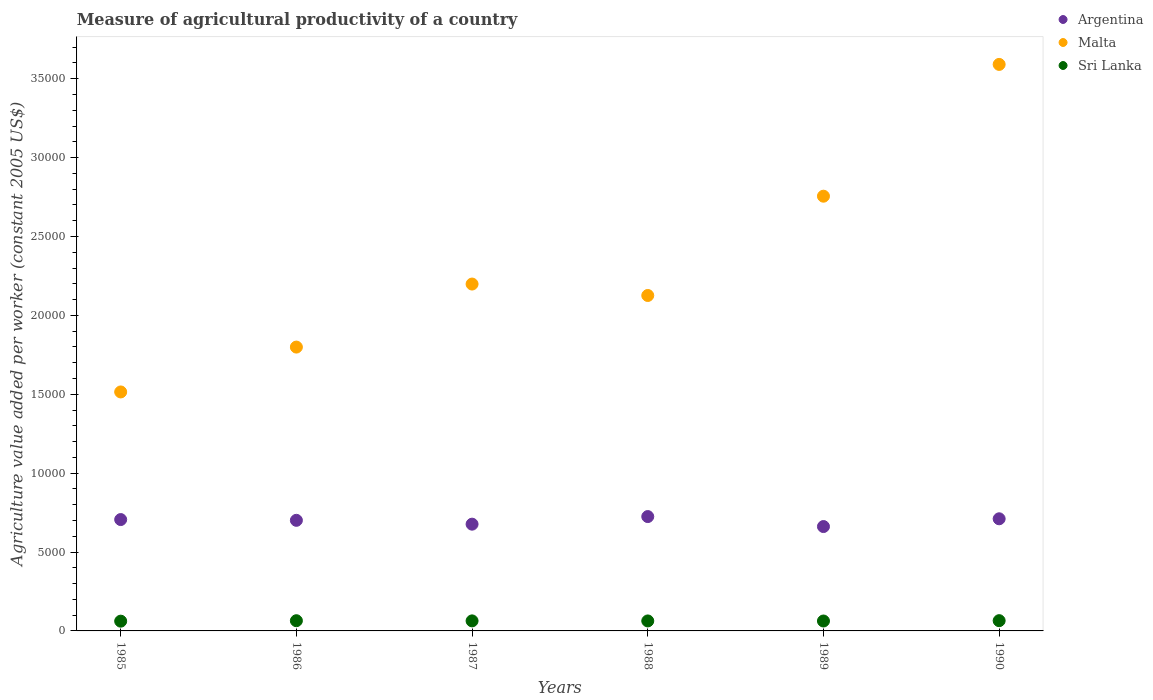What is the measure of agricultural productivity in Sri Lanka in 1986?
Offer a terse response. 646.87. Across all years, what is the maximum measure of agricultural productivity in Malta?
Your answer should be compact. 3.59e+04. Across all years, what is the minimum measure of agricultural productivity in Sri Lanka?
Your answer should be very brief. 618.17. In which year was the measure of agricultural productivity in Malta maximum?
Give a very brief answer. 1990. What is the total measure of agricultural productivity in Sri Lanka in the graph?
Give a very brief answer. 3811.92. What is the difference between the measure of agricultural productivity in Sri Lanka in 1987 and that in 1990?
Give a very brief answer. -14.21. What is the difference between the measure of agricultural productivity in Sri Lanka in 1985 and the measure of agricultural productivity in Malta in 1987?
Your answer should be very brief. -2.14e+04. What is the average measure of agricultural productivity in Argentina per year?
Offer a terse response. 6967.93. In the year 1985, what is the difference between the measure of agricultural productivity in Malta and measure of agricultural productivity in Argentina?
Give a very brief answer. 8089.08. In how many years, is the measure of agricultural productivity in Sri Lanka greater than 25000 US$?
Provide a succinct answer. 0. What is the ratio of the measure of agricultural productivity in Malta in 1987 to that in 1989?
Offer a very short reply. 0.8. Is the measure of agricultural productivity in Sri Lanka in 1986 less than that in 1988?
Make the answer very short. No. Is the difference between the measure of agricultural productivity in Malta in 1986 and 1988 greater than the difference between the measure of agricultural productivity in Argentina in 1986 and 1988?
Make the answer very short. No. What is the difference between the highest and the second highest measure of agricultural productivity in Sri Lanka?
Your answer should be very brief. 3.16. What is the difference between the highest and the lowest measure of agricultural productivity in Sri Lanka?
Provide a short and direct response. 31.86. In how many years, is the measure of agricultural productivity in Argentina greater than the average measure of agricultural productivity in Argentina taken over all years?
Keep it short and to the point. 4. Is it the case that in every year, the sum of the measure of agricultural productivity in Sri Lanka and measure of agricultural productivity in Malta  is greater than the measure of agricultural productivity in Argentina?
Keep it short and to the point. Yes. Is the measure of agricultural productivity in Malta strictly greater than the measure of agricultural productivity in Sri Lanka over the years?
Your answer should be compact. Yes. How many years are there in the graph?
Keep it short and to the point. 6. What is the difference between two consecutive major ticks on the Y-axis?
Offer a very short reply. 5000. Does the graph contain any zero values?
Offer a terse response. No. How many legend labels are there?
Offer a terse response. 3. What is the title of the graph?
Offer a very short reply. Measure of agricultural productivity of a country. What is the label or title of the X-axis?
Offer a terse response. Years. What is the label or title of the Y-axis?
Keep it short and to the point. Agriculture value added per worker (constant 2005 US$). What is the Agriculture value added per worker (constant 2005 US$) of Argentina in 1985?
Keep it short and to the point. 7058.64. What is the Agriculture value added per worker (constant 2005 US$) in Malta in 1985?
Provide a short and direct response. 1.51e+04. What is the Agriculture value added per worker (constant 2005 US$) in Sri Lanka in 1985?
Offer a very short reply. 618.17. What is the Agriculture value added per worker (constant 2005 US$) in Argentina in 1986?
Make the answer very short. 7010.49. What is the Agriculture value added per worker (constant 2005 US$) in Malta in 1986?
Your answer should be very brief. 1.80e+04. What is the Agriculture value added per worker (constant 2005 US$) in Sri Lanka in 1986?
Your response must be concise. 646.87. What is the Agriculture value added per worker (constant 2005 US$) in Argentina in 1987?
Make the answer very short. 6766.74. What is the Agriculture value added per worker (constant 2005 US$) in Malta in 1987?
Keep it short and to the point. 2.20e+04. What is the Agriculture value added per worker (constant 2005 US$) in Sri Lanka in 1987?
Keep it short and to the point. 635.83. What is the Agriculture value added per worker (constant 2005 US$) in Argentina in 1988?
Your answer should be compact. 7248.35. What is the Agriculture value added per worker (constant 2005 US$) of Malta in 1988?
Make the answer very short. 2.13e+04. What is the Agriculture value added per worker (constant 2005 US$) in Sri Lanka in 1988?
Offer a terse response. 632.87. What is the Agriculture value added per worker (constant 2005 US$) of Argentina in 1989?
Give a very brief answer. 6615.78. What is the Agriculture value added per worker (constant 2005 US$) of Malta in 1989?
Make the answer very short. 2.76e+04. What is the Agriculture value added per worker (constant 2005 US$) of Sri Lanka in 1989?
Provide a succinct answer. 628.14. What is the Agriculture value added per worker (constant 2005 US$) of Argentina in 1990?
Keep it short and to the point. 7107.59. What is the Agriculture value added per worker (constant 2005 US$) in Malta in 1990?
Your answer should be compact. 3.59e+04. What is the Agriculture value added per worker (constant 2005 US$) of Sri Lanka in 1990?
Provide a short and direct response. 650.03. Across all years, what is the maximum Agriculture value added per worker (constant 2005 US$) in Argentina?
Offer a very short reply. 7248.35. Across all years, what is the maximum Agriculture value added per worker (constant 2005 US$) of Malta?
Your response must be concise. 3.59e+04. Across all years, what is the maximum Agriculture value added per worker (constant 2005 US$) of Sri Lanka?
Provide a succinct answer. 650.03. Across all years, what is the minimum Agriculture value added per worker (constant 2005 US$) of Argentina?
Offer a very short reply. 6615.78. Across all years, what is the minimum Agriculture value added per worker (constant 2005 US$) in Malta?
Your response must be concise. 1.51e+04. Across all years, what is the minimum Agriculture value added per worker (constant 2005 US$) in Sri Lanka?
Provide a succinct answer. 618.17. What is the total Agriculture value added per worker (constant 2005 US$) of Argentina in the graph?
Make the answer very short. 4.18e+04. What is the total Agriculture value added per worker (constant 2005 US$) of Malta in the graph?
Provide a short and direct response. 1.40e+05. What is the total Agriculture value added per worker (constant 2005 US$) of Sri Lanka in the graph?
Give a very brief answer. 3811.92. What is the difference between the Agriculture value added per worker (constant 2005 US$) in Argentina in 1985 and that in 1986?
Make the answer very short. 48.16. What is the difference between the Agriculture value added per worker (constant 2005 US$) in Malta in 1985 and that in 1986?
Ensure brevity in your answer.  -2843.98. What is the difference between the Agriculture value added per worker (constant 2005 US$) of Sri Lanka in 1985 and that in 1986?
Your answer should be very brief. -28.7. What is the difference between the Agriculture value added per worker (constant 2005 US$) of Argentina in 1985 and that in 1987?
Provide a succinct answer. 291.9. What is the difference between the Agriculture value added per worker (constant 2005 US$) in Malta in 1985 and that in 1987?
Give a very brief answer. -6839.31. What is the difference between the Agriculture value added per worker (constant 2005 US$) in Sri Lanka in 1985 and that in 1987?
Your answer should be very brief. -17.65. What is the difference between the Agriculture value added per worker (constant 2005 US$) in Argentina in 1985 and that in 1988?
Make the answer very short. -189.71. What is the difference between the Agriculture value added per worker (constant 2005 US$) in Malta in 1985 and that in 1988?
Provide a succinct answer. -6114.57. What is the difference between the Agriculture value added per worker (constant 2005 US$) of Sri Lanka in 1985 and that in 1988?
Provide a short and direct response. -14.7. What is the difference between the Agriculture value added per worker (constant 2005 US$) of Argentina in 1985 and that in 1989?
Provide a succinct answer. 442.86. What is the difference between the Agriculture value added per worker (constant 2005 US$) of Malta in 1985 and that in 1989?
Your answer should be compact. -1.24e+04. What is the difference between the Agriculture value added per worker (constant 2005 US$) in Sri Lanka in 1985 and that in 1989?
Provide a succinct answer. -9.97. What is the difference between the Agriculture value added per worker (constant 2005 US$) of Argentina in 1985 and that in 1990?
Offer a very short reply. -48.95. What is the difference between the Agriculture value added per worker (constant 2005 US$) in Malta in 1985 and that in 1990?
Make the answer very short. -2.08e+04. What is the difference between the Agriculture value added per worker (constant 2005 US$) of Sri Lanka in 1985 and that in 1990?
Your answer should be compact. -31.86. What is the difference between the Agriculture value added per worker (constant 2005 US$) in Argentina in 1986 and that in 1987?
Offer a very short reply. 243.75. What is the difference between the Agriculture value added per worker (constant 2005 US$) in Malta in 1986 and that in 1987?
Your answer should be very brief. -3995.34. What is the difference between the Agriculture value added per worker (constant 2005 US$) of Sri Lanka in 1986 and that in 1987?
Your response must be concise. 11.05. What is the difference between the Agriculture value added per worker (constant 2005 US$) in Argentina in 1986 and that in 1988?
Offer a terse response. -237.87. What is the difference between the Agriculture value added per worker (constant 2005 US$) of Malta in 1986 and that in 1988?
Your answer should be compact. -3270.59. What is the difference between the Agriculture value added per worker (constant 2005 US$) of Sri Lanka in 1986 and that in 1988?
Offer a very short reply. 14. What is the difference between the Agriculture value added per worker (constant 2005 US$) in Argentina in 1986 and that in 1989?
Your answer should be compact. 394.7. What is the difference between the Agriculture value added per worker (constant 2005 US$) of Malta in 1986 and that in 1989?
Offer a very short reply. -9564.66. What is the difference between the Agriculture value added per worker (constant 2005 US$) of Sri Lanka in 1986 and that in 1989?
Make the answer very short. 18.73. What is the difference between the Agriculture value added per worker (constant 2005 US$) in Argentina in 1986 and that in 1990?
Offer a very short reply. -97.11. What is the difference between the Agriculture value added per worker (constant 2005 US$) of Malta in 1986 and that in 1990?
Ensure brevity in your answer.  -1.79e+04. What is the difference between the Agriculture value added per worker (constant 2005 US$) in Sri Lanka in 1986 and that in 1990?
Offer a very short reply. -3.16. What is the difference between the Agriculture value added per worker (constant 2005 US$) of Argentina in 1987 and that in 1988?
Offer a terse response. -481.61. What is the difference between the Agriculture value added per worker (constant 2005 US$) of Malta in 1987 and that in 1988?
Your answer should be compact. 724.74. What is the difference between the Agriculture value added per worker (constant 2005 US$) in Sri Lanka in 1987 and that in 1988?
Your answer should be compact. 2.95. What is the difference between the Agriculture value added per worker (constant 2005 US$) in Argentina in 1987 and that in 1989?
Offer a very short reply. 150.95. What is the difference between the Agriculture value added per worker (constant 2005 US$) in Malta in 1987 and that in 1989?
Give a very brief answer. -5569.33. What is the difference between the Agriculture value added per worker (constant 2005 US$) of Sri Lanka in 1987 and that in 1989?
Make the answer very short. 7.68. What is the difference between the Agriculture value added per worker (constant 2005 US$) of Argentina in 1987 and that in 1990?
Give a very brief answer. -340.85. What is the difference between the Agriculture value added per worker (constant 2005 US$) in Malta in 1987 and that in 1990?
Make the answer very short. -1.39e+04. What is the difference between the Agriculture value added per worker (constant 2005 US$) of Sri Lanka in 1987 and that in 1990?
Your response must be concise. -14.21. What is the difference between the Agriculture value added per worker (constant 2005 US$) of Argentina in 1988 and that in 1989?
Provide a short and direct response. 632.57. What is the difference between the Agriculture value added per worker (constant 2005 US$) of Malta in 1988 and that in 1989?
Offer a terse response. -6294.07. What is the difference between the Agriculture value added per worker (constant 2005 US$) in Sri Lanka in 1988 and that in 1989?
Ensure brevity in your answer.  4.73. What is the difference between the Agriculture value added per worker (constant 2005 US$) in Argentina in 1988 and that in 1990?
Provide a succinct answer. 140.76. What is the difference between the Agriculture value added per worker (constant 2005 US$) of Malta in 1988 and that in 1990?
Make the answer very short. -1.46e+04. What is the difference between the Agriculture value added per worker (constant 2005 US$) in Sri Lanka in 1988 and that in 1990?
Offer a terse response. -17.16. What is the difference between the Agriculture value added per worker (constant 2005 US$) of Argentina in 1989 and that in 1990?
Make the answer very short. -491.81. What is the difference between the Agriculture value added per worker (constant 2005 US$) of Malta in 1989 and that in 1990?
Ensure brevity in your answer.  -8353.06. What is the difference between the Agriculture value added per worker (constant 2005 US$) in Sri Lanka in 1989 and that in 1990?
Keep it short and to the point. -21.89. What is the difference between the Agriculture value added per worker (constant 2005 US$) in Argentina in 1985 and the Agriculture value added per worker (constant 2005 US$) in Malta in 1986?
Offer a very short reply. -1.09e+04. What is the difference between the Agriculture value added per worker (constant 2005 US$) in Argentina in 1985 and the Agriculture value added per worker (constant 2005 US$) in Sri Lanka in 1986?
Ensure brevity in your answer.  6411.77. What is the difference between the Agriculture value added per worker (constant 2005 US$) of Malta in 1985 and the Agriculture value added per worker (constant 2005 US$) of Sri Lanka in 1986?
Your answer should be compact. 1.45e+04. What is the difference between the Agriculture value added per worker (constant 2005 US$) in Argentina in 1985 and the Agriculture value added per worker (constant 2005 US$) in Malta in 1987?
Offer a terse response. -1.49e+04. What is the difference between the Agriculture value added per worker (constant 2005 US$) in Argentina in 1985 and the Agriculture value added per worker (constant 2005 US$) in Sri Lanka in 1987?
Provide a succinct answer. 6422.82. What is the difference between the Agriculture value added per worker (constant 2005 US$) in Malta in 1985 and the Agriculture value added per worker (constant 2005 US$) in Sri Lanka in 1987?
Offer a very short reply. 1.45e+04. What is the difference between the Agriculture value added per worker (constant 2005 US$) of Argentina in 1985 and the Agriculture value added per worker (constant 2005 US$) of Malta in 1988?
Ensure brevity in your answer.  -1.42e+04. What is the difference between the Agriculture value added per worker (constant 2005 US$) of Argentina in 1985 and the Agriculture value added per worker (constant 2005 US$) of Sri Lanka in 1988?
Provide a short and direct response. 6425.77. What is the difference between the Agriculture value added per worker (constant 2005 US$) of Malta in 1985 and the Agriculture value added per worker (constant 2005 US$) of Sri Lanka in 1988?
Give a very brief answer. 1.45e+04. What is the difference between the Agriculture value added per worker (constant 2005 US$) in Argentina in 1985 and the Agriculture value added per worker (constant 2005 US$) in Malta in 1989?
Your response must be concise. -2.05e+04. What is the difference between the Agriculture value added per worker (constant 2005 US$) of Argentina in 1985 and the Agriculture value added per worker (constant 2005 US$) of Sri Lanka in 1989?
Your answer should be compact. 6430.5. What is the difference between the Agriculture value added per worker (constant 2005 US$) in Malta in 1985 and the Agriculture value added per worker (constant 2005 US$) in Sri Lanka in 1989?
Offer a very short reply. 1.45e+04. What is the difference between the Agriculture value added per worker (constant 2005 US$) of Argentina in 1985 and the Agriculture value added per worker (constant 2005 US$) of Malta in 1990?
Provide a short and direct response. -2.89e+04. What is the difference between the Agriculture value added per worker (constant 2005 US$) of Argentina in 1985 and the Agriculture value added per worker (constant 2005 US$) of Sri Lanka in 1990?
Offer a terse response. 6408.61. What is the difference between the Agriculture value added per worker (constant 2005 US$) of Malta in 1985 and the Agriculture value added per worker (constant 2005 US$) of Sri Lanka in 1990?
Your answer should be compact. 1.45e+04. What is the difference between the Agriculture value added per worker (constant 2005 US$) of Argentina in 1986 and the Agriculture value added per worker (constant 2005 US$) of Malta in 1987?
Make the answer very short. -1.50e+04. What is the difference between the Agriculture value added per worker (constant 2005 US$) of Argentina in 1986 and the Agriculture value added per worker (constant 2005 US$) of Sri Lanka in 1987?
Your response must be concise. 6374.66. What is the difference between the Agriculture value added per worker (constant 2005 US$) of Malta in 1986 and the Agriculture value added per worker (constant 2005 US$) of Sri Lanka in 1987?
Provide a succinct answer. 1.74e+04. What is the difference between the Agriculture value added per worker (constant 2005 US$) in Argentina in 1986 and the Agriculture value added per worker (constant 2005 US$) in Malta in 1988?
Provide a succinct answer. -1.43e+04. What is the difference between the Agriculture value added per worker (constant 2005 US$) of Argentina in 1986 and the Agriculture value added per worker (constant 2005 US$) of Sri Lanka in 1988?
Give a very brief answer. 6377.61. What is the difference between the Agriculture value added per worker (constant 2005 US$) of Malta in 1986 and the Agriculture value added per worker (constant 2005 US$) of Sri Lanka in 1988?
Make the answer very short. 1.74e+04. What is the difference between the Agriculture value added per worker (constant 2005 US$) of Argentina in 1986 and the Agriculture value added per worker (constant 2005 US$) of Malta in 1989?
Give a very brief answer. -2.05e+04. What is the difference between the Agriculture value added per worker (constant 2005 US$) in Argentina in 1986 and the Agriculture value added per worker (constant 2005 US$) in Sri Lanka in 1989?
Your answer should be compact. 6382.34. What is the difference between the Agriculture value added per worker (constant 2005 US$) in Malta in 1986 and the Agriculture value added per worker (constant 2005 US$) in Sri Lanka in 1989?
Your response must be concise. 1.74e+04. What is the difference between the Agriculture value added per worker (constant 2005 US$) in Argentina in 1986 and the Agriculture value added per worker (constant 2005 US$) in Malta in 1990?
Your response must be concise. -2.89e+04. What is the difference between the Agriculture value added per worker (constant 2005 US$) of Argentina in 1986 and the Agriculture value added per worker (constant 2005 US$) of Sri Lanka in 1990?
Provide a succinct answer. 6360.45. What is the difference between the Agriculture value added per worker (constant 2005 US$) of Malta in 1986 and the Agriculture value added per worker (constant 2005 US$) of Sri Lanka in 1990?
Ensure brevity in your answer.  1.73e+04. What is the difference between the Agriculture value added per worker (constant 2005 US$) of Argentina in 1987 and the Agriculture value added per worker (constant 2005 US$) of Malta in 1988?
Give a very brief answer. -1.45e+04. What is the difference between the Agriculture value added per worker (constant 2005 US$) of Argentina in 1987 and the Agriculture value added per worker (constant 2005 US$) of Sri Lanka in 1988?
Ensure brevity in your answer.  6133.87. What is the difference between the Agriculture value added per worker (constant 2005 US$) in Malta in 1987 and the Agriculture value added per worker (constant 2005 US$) in Sri Lanka in 1988?
Offer a very short reply. 2.14e+04. What is the difference between the Agriculture value added per worker (constant 2005 US$) in Argentina in 1987 and the Agriculture value added per worker (constant 2005 US$) in Malta in 1989?
Provide a short and direct response. -2.08e+04. What is the difference between the Agriculture value added per worker (constant 2005 US$) of Argentina in 1987 and the Agriculture value added per worker (constant 2005 US$) of Sri Lanka in 1989?
Offer a very short reply. 6138.6. What is the difference between the Agriculture value added per worker (constant 2005 US$) in Malta in 1987 and the Agriculture value added per worker (constant 2005 US$) in Sri Lanka in 1989?
Your answer should be very brief. 2.14e+04. What is the difference between the Agriculture value added per worker (constant 2005 US$) in Argentina in 1987 and the Agriculture value added per worker (constant 2005 US$) in Malta in 1990?
Provide a succinct answer. -2.91e+04. What is the difference between the Agriculture value added per worker (constant 2005 US$) of Argentina in 1987 and the Agriculture value added per worker (constant 2005 US$) of Sri Lanka in 1990?
Provide a short and direct response. 6116.71. What is the difference between the Agriculture value added per worker (constant 2005 US$) in Malta in 1987 and the Agriculture value added per worker (constant 2005 US$) in Sri Lanka in 1990?
Your response must be concise. 2.13e+04. What is the difference between the Agriculture value added per worker (constant 2005 US$) of Argentina in 1988 and the Agriculture value added per worker (constant 2005 US$) of Malta in 1989?
Offer a terse response. -2.03e+04. What is the difference between the Agriculture value added per worker (constant 2005 US$) of Argentina in 1988 and the Agriculture value added per worker (constant 2005 US$) of Sri Lanka in 1989?
Provide a succinct answer. 6620.21. What is the difference between the Agriculture value added per worker (constant 2005 US$) of Malta in 1988 and the Agriculture value added per worker (constant 2005 US$) of Sri Lanka in 1989?
Your response must be concise. 2.06e+04. What is the difference between the Agriculture value added per worker (constant 2005 US$) in Argentina in 1988 and the Agriculture value added per worker (constant 2005 US$) in Malta in 1990?
Ensure brevity in your answer.  -2.87e+04. What is the difference between the Agriculture value added per worker (constant 2005 US$) of Argentina in 1988 and the Agriculture value added per worker (constant 2005 US$) of Sri Lanka in 1990?
Keep it short and to the point. 6598.32. What is the difference between the Agriculture value added per worker (constant 2005 US$) of Malta in 1988 and the Agriculture value added per worker (constant 2005 US$) of Sri Lanka in 1990?
Ensure brevity in your answer.  2.06e+04. What is the difference between the Agriculture value added per worker (constant 2005 US$) in Argentina in 1989 and the Agriculture value added per worker (constant 2005 US$) in Malta in 1990?
Provide a succinct answer. -2.93e+04. What is the difference between the Agriculture value added per worker (constant 2005 US$) of Argentina in 1989 and the Agriculture value added per worker (constant 2005 US$) of Sri Lanka in 1990?
Provide a short and direct response. 5965.75. What is the difference between the Agriculture value added per worker (constant 2005 US$) in Malta in 1989 and the Agriculture value added per worker (constant 2005 US$) in Sri Lanka in 1990?
Provide a short and direct response. 2.69e+04. What is the average Agriculture value added per worker (constant 2005 US$) of Argentina per year?
Your answer should be very brief. 6967.93. What is the average Agriculture value added per worker (constant 2005 US$) in Malta per year?
Provide a succinct answer. 2.33e+04. What is the average Agriculture value added per worker (constant 2005 US$) in Sri Lanka per year?
Your response must be concise. 635.32. In the year 1985, what is the difference between the Agriculture value added per worker (constant 2005 US$) of Argentina and Agriculture value added per worker (constant 2005 US$) of Malta?
Ensure brevity in your answer.  -8089.08. In the year 1985, what is the difference between the Agriculture value added per worker (constant 2005 US$) of Argentina and Agriculture value added per worker (constant 2005 US$) of Sri Lanka?
Your response must be concise. 6440.47. In the year 1985, what is the difference between the Agriculture value added per worker (constant 2005 US$) of Malta and Agriculture value added per worker (constant 2005 US$) of Sri Lanka?
Your answer should be compact. 1.45e+04. In the year 1986, what is the difference between the Agriculture value added per worker (constant 2005 US$) in Argentina and Agriculture value added per worker (constant 2005 US$) in Malta?
Provide a short and direct response. -1.10e+04. In the year 1986, what is the difference between the Agriculture value added per worker (constant 2005 US$) of Argentina and Agriculture value added per worker (constant 2005 US$) of Sri Lanka?
Ensure brevity in your answer.  6363.61. In the year 1986, what is the difference between the Agriculture value added per worker (constant 2005 US$) in Malta and Agriculture value added per worker (constant 2005 US$) in Sri Lanka?
Your answer should be very brief. 1.73e+04. In the year 1987, what is the difference between the Agriculture value added per worker (constant 2005 US$) of Argentina and Agriculture value added per worker (constant 2005 US$) of Malta?
Your response must be concise. -1.52e+04. In the year 1987, what is the difference between the Agriculture value added per worker (constant 2005 US$) of Argentina and Agriculture value added per worker (constant 2005 US$) of Sri Lanka?
Provide a succinct answer. 6130.91. In the year 1987, what is the difference between the Agriculture value added per worker (constant 2005 US$) of Malta and Agriculture value added per worker (constant 2005 US$) of Sri Lanka?
Provide a short and direct response. 2.14e+04. In the year 1988, what is the difference between the Agriculture value added per worker (constant 2005 US$) of Argentina and Agriculture value added per worker (constant 2005 US$) of Malta?
Give a very brief answer. -1.40e+04. In the year 1988, what is the difference between the Agriculture value added per worker (constant 2005 US$) in Argentina and Agriculture value added per worker (constant 2005 US$) in Sri Lanka?
Give a very brief answer. 6615.48. In the year 1988, what is the difference between the Agriculture value added per worker (constant 2005 US$) of Malta and Agriculture value added per worker (constant 2005 US$) of Sri Lanka?
Make the answer very short. 2.06e+04. In the year 1989, what is the difference between the Agriculture value added per worker (constant 2005 US$) of Argentina and Agriculture value added per worker (constant 2005 US$) of Malta?
Your answer should be compact. -2.09e+04. In the year 1989, what is the difference between the Agriculture value added per worker (constant 2005 US$) in Argentina and Agriculture value added per worker (constant 2005 US$) in Sri Lanka?
Provide a succinct answer. 5987.64. In the year 1989, what is the difference between the Agriculture value added per worker (constant 2005 US$) of Malta and Agriculture value added per worker (constant 2005 US$) of Sri Lanka?
Your response must be concise. 2.69e+04. In the year 1990, what is the difference between the Agriculture value added per worker (constant 2005 US$) of Argentina and Agriculture value added per worker (constant 2005 US$) of Malta?
Your answer should be very brief. -2.88e+04. In the year 1990, what is the difference between the Agriculture value added per worker (constant 2005 US$) in Argentina and Agriculture value added per worker (constant 2005 US$) in Sri Lanka?
Make the answer very short. 6457.56. In the year 1990, what is the difference between the Agriculture value added per worker (constant 2005 US$) in Malta and Agriculture value added per worker (constant 2005 US$) in Sri Lanka?
Your answer should be compact. 3.53e+04. What is the ratio of the Agriculture value added per worker (constant 2005 US$) in Malta in 1985 to that in 1986?
Make the answer very short. 0.84. What is the ratio of the Agriculture value added per worker (constant 2005 US$) of Sri Lanka in 1985 to that in 1986?
Give a very brief answer. 0.96. What is the ratio of the Agriculture value added per worker (constant 2005 US$) of Argentina in 1985 to that in 1987?
Offer a terse response. 1.04. What is the ratio of the Agriculture value added per worker (constant 2005 US$) in Malta in 1985 to that in 1987?
Ensure brevity in your answer.  0.69. What is the ratio of the Agriculture value added per worker (constant 2005 US$) of Sri Lanka in 1985 to that in 1987?
Your answer should be compact. 0.97. What is the ratio of the Agriculture value added per worker (constant 2005 US$) in Argentina in 1985 to that in 1988?
Your answer should be very brief. 0.97. What is the ratio of the Agriculture value added per worker (constant 2005 US$) in Malta in 1985 to that in 1988?
Provide a short and direct response. 0.71. What is the ratio of the Agriculture value added per worker (constant 2005 US$) of Sri Lanka in 1985 to that in 1988?
Give a very brief answer. 0.98. What is the ratio of the Agriculture value added per worker (constant 2005 US$) of Argentina in 1985 to that in 1989?
Your response must be concise. 1.07. What is the ratio of the Agriculture value added per worker (constant 2005 US$) in Malta in 1985 to that in 1989?
Your answer should be compact. 0.55. What is the ratio of the Agriculture value added per worker (constant 2005 US$) in Sri Lanka in 1985 to that in 1989?
Offer a terse response. 0.98. What is the ratio of the Agriculture value added per worker (constant 2005 US$) of Argentina in 1985 to that in 1990?
Provide a succinct answer. 0.99. What is the ratio of the Agriculture value added per worker (constant 2005 US$) of Malta in 1985 to that in 1990?
Your response must be concise. 0.42. What is the ratio of the Agriculture value added per worker (constant 2005 US$) in Sri Lanka in 1985 to that in 1990?
Your answer should be compact. 0.95. What is the ratio of the Agriculture value added per worker (constant 2005 US$) in Argentina in 1986 to that in 1987?
Make the answer very short. 1.04. What is the ratio of the Agriculture value added per worker (constant 2005 US$) in Malta in 1986 to that in 1987?
Provide a short and direct response. 0.82. What is the ratio of the Agriculture value added per worker (constant 2005 US$) in Sri Lanka in 1986 to that in 1987?
Offer a terse response. 1.02. What is the ratio of the Agriculture value added per worker (constant 2005 US$) in Argentina in 1986 to that in 1988?
Provide a succinct answer. 0.97. What is the ratio of the Agriculture value added per worker (constant 2005 US$) in Malta in 1986 to that in 1988?
Provide a short and direct response. 0.85. What is the ratio of the Agriculture value added per worker (constant 2005 US$) of Sri Lanka in 1986 to that in 1988?
Give a very brief answer. 1.02. What is the ratio of the Agriculture value added per worker (constant 2005 US$) in Argentina in 1986 to that in 1989?
Ensure brevity in your answer.  1.06. What is the ratio of the Agriculture value added per worker (constant 2005 US$) of Malta in 1986 to that in 1989?
Offer a very short reply. 0.65. What is the ratio of the Agriculture value added per worker (constant 2005 US$) of Sri Lanka in 1986 to that in 1989?
Provide a succinct answer. 1.03. What is the ratio of the Agriculture value added per worker (constant 2005 US$) of Argentina in 1986 to that in 1990?
Your response must be concise. 0.99. What is the ratio of the Agriculture value added per worker (constant 2005 US$) in Malta in 1986 to that in 1990?
Make the answer very short. 0.5. What is the ratio of the Agriculture value added per worker (constant 2005 US$) of Sri Lanka in 1986 to that in 1990?
Your answer should be compact. 1. What is the ratio of the Agriculture value added per worker (constant 2005 US$) in Argentina in 1987 to that in 1988?
Your answer should be compact. 0.93. What is the ratio of the Agriculture value added per worker (constant 2005 US$) in Malta in 1987 to that in 1988?
Give a very brief answer. 1.03. What is the ratio of the Agriculture value added per worker (constant 2005 US$) of Sri Lanka in 1987 to that in 1988?
Provide a short and direct response. 1. What is the ratio of the Agriculture value added per worker (constant 2005 US$) in Argentina in 1987 to that in 1989?
Your answer should be very brief. 1.02. What is the ratio of the Agriculture value added per worker (constant 2005 US$) of Malta in 1987 to that in 1989?
Your answer should be very brief. 0.8. What is the ratio of the Agriculture value added per worker (constant 2005 US$) in Sri Lanka in 1987 to that in 1989?
Keep it short and to the point. 1.01. What is the ratio of the Agriculture value added per worker (constant 2005 US$) in Argentina in 1987 to that in 1990?
Provide a short and direct response. 0.95. What is the ratio of the Agriculture value added per worker (constant 2005 US$) of Malta in 1987 to that in 1990?
Make the answer very short. 0.61. What is the ratio of the Agriculture value added per worker (constant 2005 US$) of Sri Lanka in 1987 to that in 1990?
Keep it short and to the point. 0.98. What is the ratio of the Agriculture value added per worker (constant 2005 US$) in Argentina in 1988 to that in 1989?
Keep it short and to the point. 1.1. What is the ratio of the Agriculture value added per worker (constant 2005 US$) in Malta in 1988 to that in 1989?
Offer a terse response. 0.77. What is the ratio of the Agriculture value added per worker (constant 2005 US$) of Sri Lanka in 1988 to that in 1989?
Provide a short and direct response. 1.01. What is the ratio of the Agriculture value added per worker (constant 2005 US$) in Argentina in 1988 to that in 1990?
Your response must be concise. 1.02. What is the ratio of the Agriculture value added per worker (constant 2005 US$) of Malta in 1988 to that in 1990?
Ensure brevity in your answer.  0.59. What is the ratio of the Agriculture value added per worker (constant 2005 US$) in Sri Lanka in 1988 to that in 1990?
Provide a short and direct response. 0.97. What is the ratio of the Agriculture value added per worker (constant 2005 US$) in Argentina in 1989 to that in 1990?
Give a very brief answer. 0.93. What is the ratio of the Agriculture value added per worker (constant 2005 US$) of Malta in 1989 to that in 1990?
Your answer should be compact. 0.77. What is the ratio of the Agriculture value added per worker (constant 2005 US$) in Sri Lanka in 1989 to that in 1990?
Keep it short and to the point. 0.97. What is the difference between the highest and the second highest Agriculture value added per worker (constant 2005 US$) in Argentina?
Offer a terse response. 140.76. What is the difference between the highest and the second highest Agriculture value added per worker (constant 2005 US$) of Malta?
Your answer should be very brief. 8353.06. What is the difference between the highest and the second highest Agriculture value added per worker (constant 2005 US$) in Sri Lanka?
Offer a terse response. 3.16. What is the difference between the highest and the lowest Agriculture value added per worker (constant 2005 US$) of Argentina?
Your answer should be very brief. 632.57. What is the difference between the highest and the lowest Agriculture value added per worker (constant 2005 US$) of Malta?
Provide a succinct answer. 2.08e+04. What is the difference between the highest and the lowest Agriculture value added per worker (constant 2005 US$) of Sri Lanka?
Offer a very short reply. 31.86. 